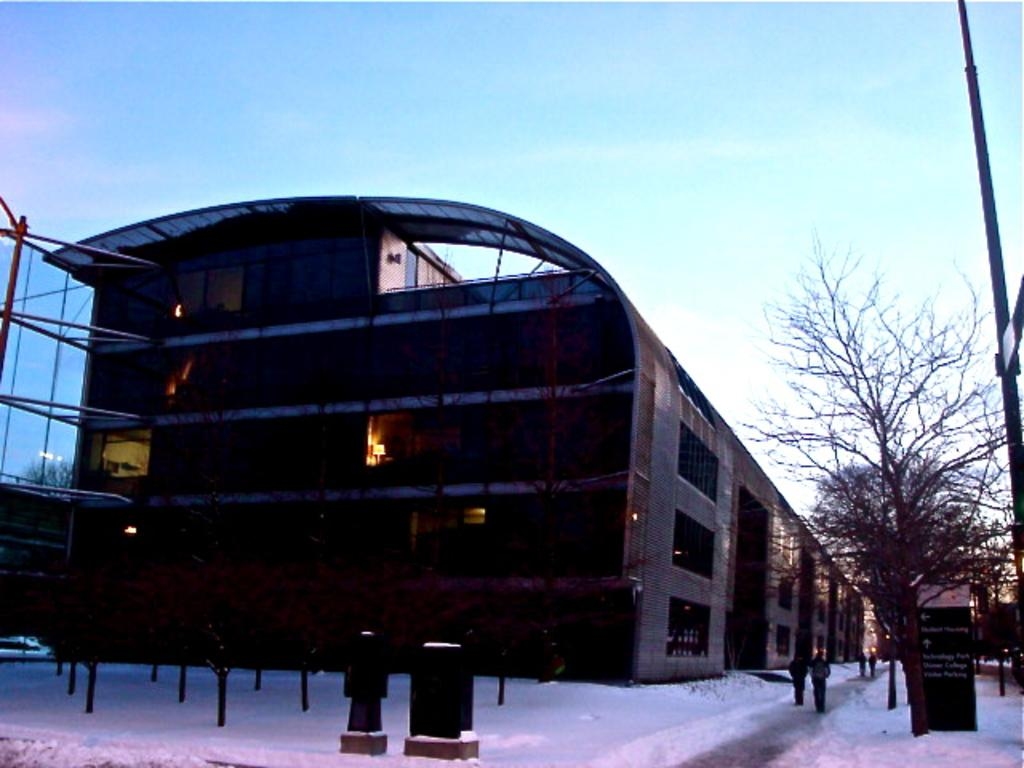What is the main structure in the middle of the image? There is a building in the middle of the image. Who or what can be seen at the bottom of the image? There are people at the bottom of the image. What objects are present in the image that resemble long, thin vertical structures? There are poles in the image. What is the texture of the surface at the bottom of the image? There is ice at the bottom of the image. What type of vegetation is on the right side of the image? There are trees on the right side of the image. What is attached to the trees on the right side of the image? There is a poster and sign boards on the right side of the image. What part of the natural environment is visible in the image? The sky is visible in the image. What type of balloon can be seen floating in the sky in the image? There are no balloons present in the image; only the building, people, poles, ice, trees, poster, sign boards, and sky are visible. 